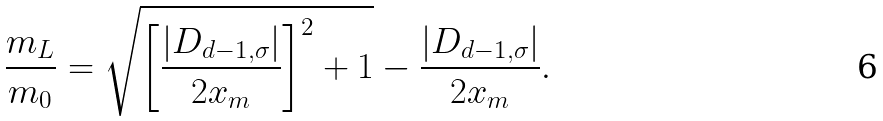<formula> <loc_0><loc_0><loc_500><loc_500>\frac { m _ { L } } { m _ { 0 } } = \sqrt { \left [ \frac { | D _ { d - 1 , \sigma } | } { 2 x _ { m } } \right ] ^ { 2 } + 1 } - \frac { | D _ { d - 1 , \sigma } | } { 2 x _ { m } } .</formula> 